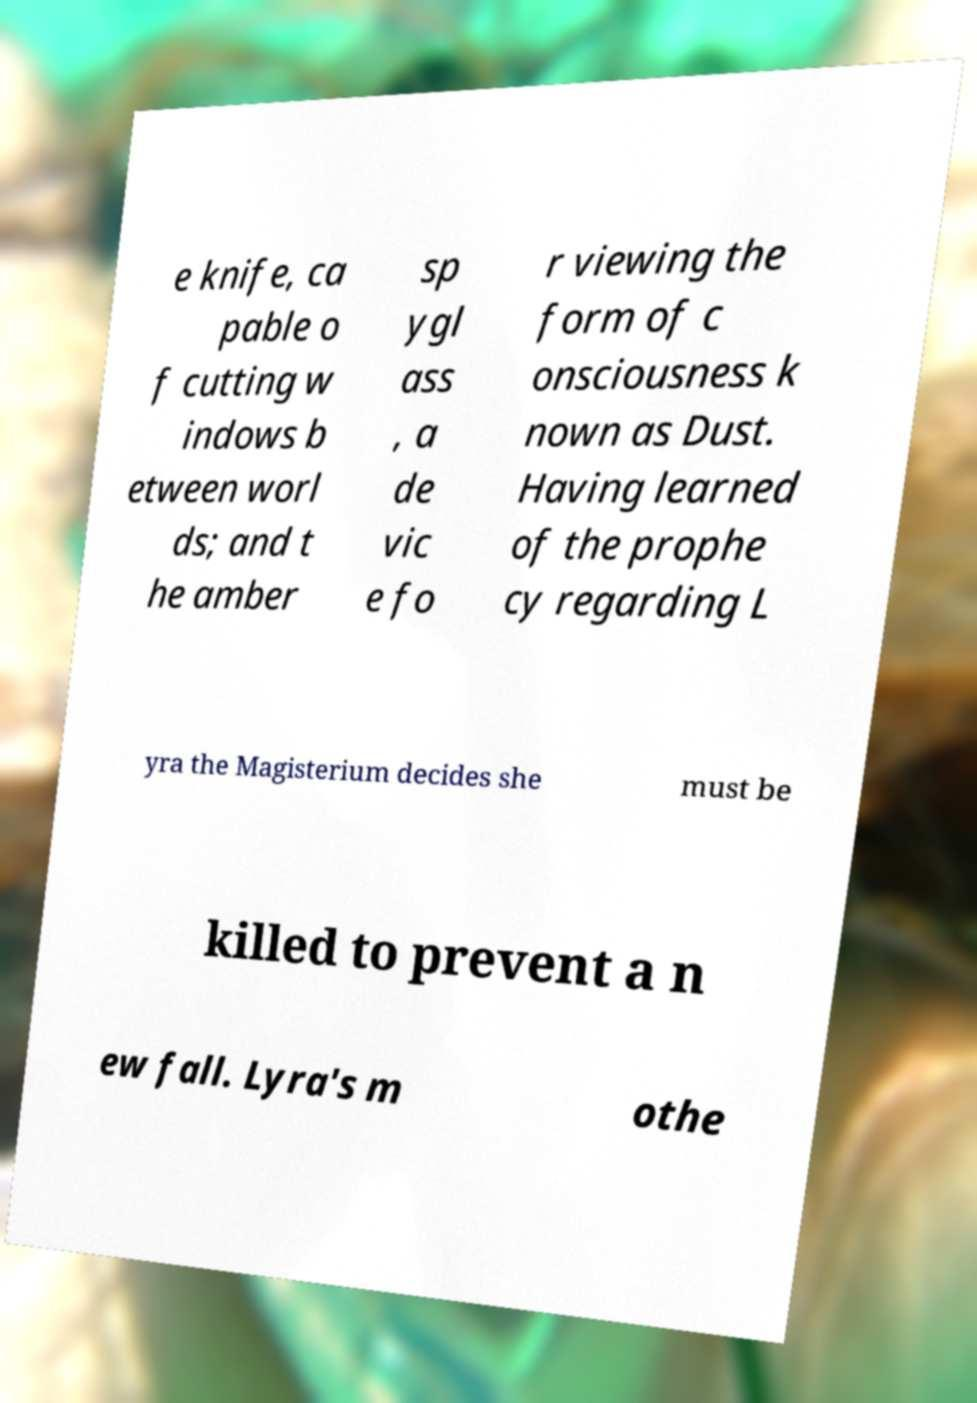There's text embedded in this image that I need extracted. Can you transcribe it verbatim? e knife, ca pable o f cutting w indows b etween worl ds; and t he amber sp ygl ass , a de vic e fo r viewing the form of c onsciousness k nown as Dust. Having learned of the prophe cy regarding L yra the Magisterium decides she must be killed to prevent a n ew fall. Lyra's m othe 